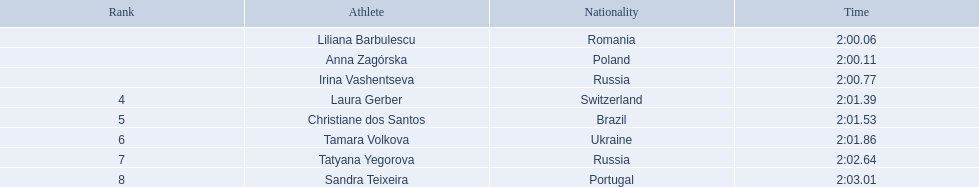Who were the female athletes participating in the 800 meters event at the 2003 summer universiade? , Liliana Barbulescu, Anna Zagórska, Irina Vashentseva, Laura Gerber, Christiane dos Santos, Tamara Volkova, Tatyana Yegorova, Sandra Teixeira. What was anna zagorska's completion time? 2:00.11. 